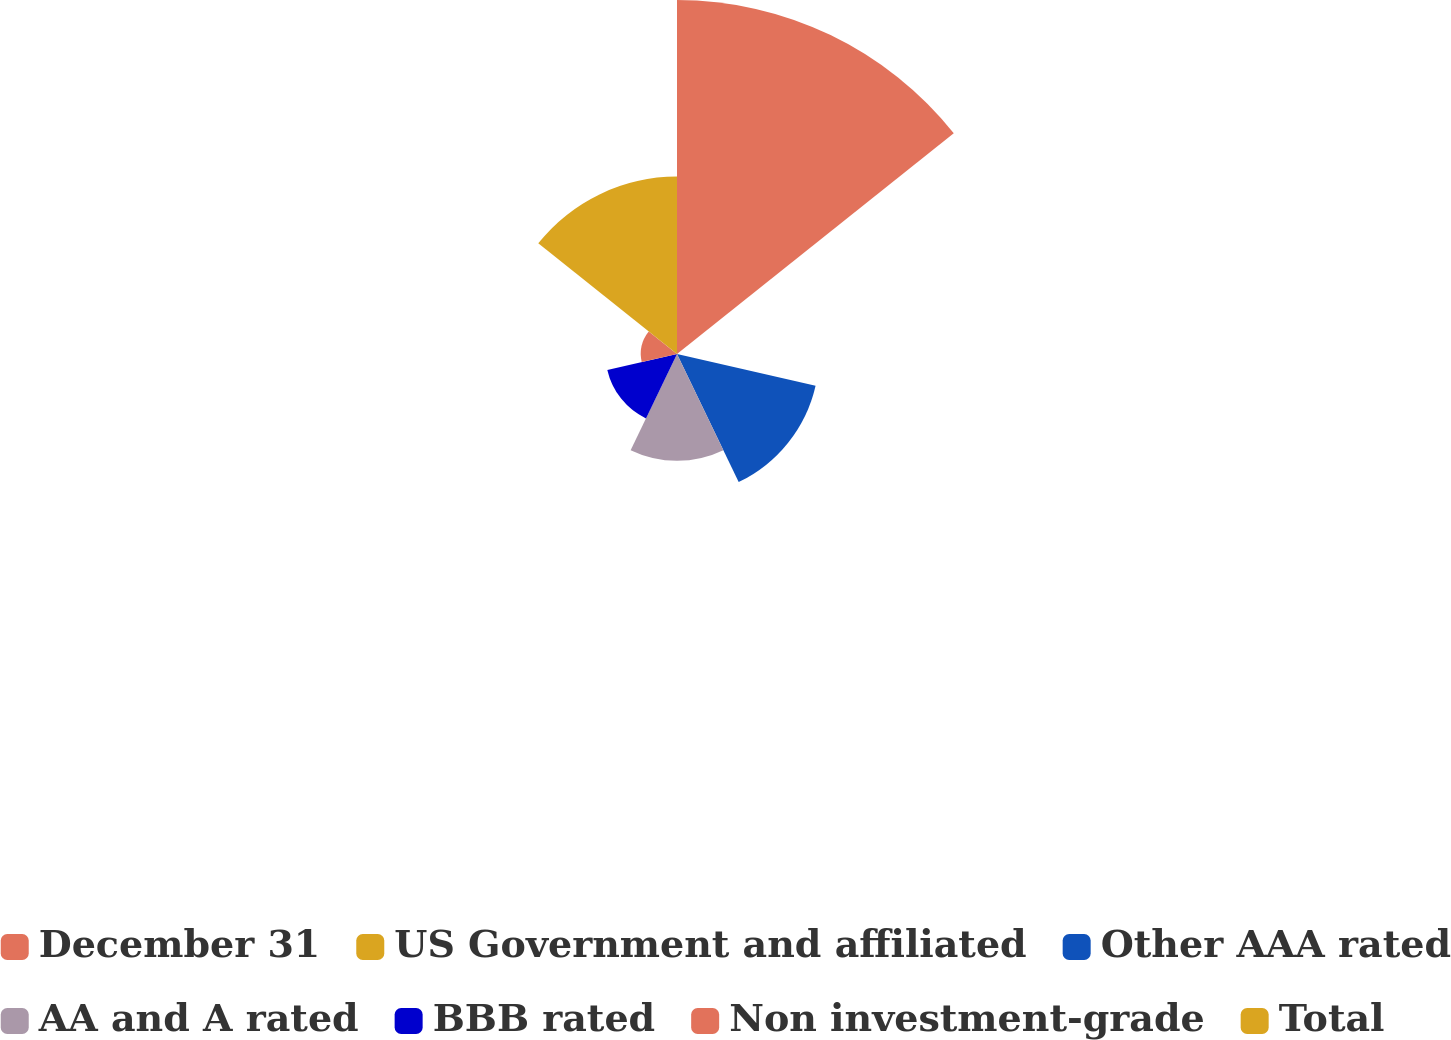Convert chart to OTSL. <chart><loc_0><loc_0><loc_500><loc_500><pie_chart><fcel>December 31<fcel>US Government and affiliated<fcel>Other AAA rated<fcel>AA and A rated<fcel>BBB rated<fcel>Non investment-grade<fcel>Total<nl><fcel>39.82%<fcel>0.1%<fcel>15.99%<fcel>12.02%<fcel>8.04%<fcel>4.07%<fcel>19.96%<nl></chart> 